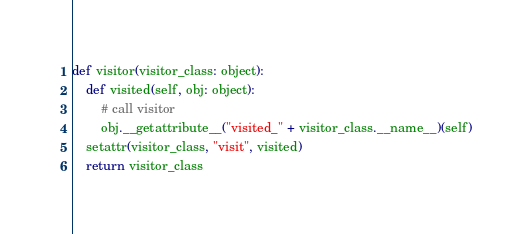<code> <loc_0><loc_0><loc_500><loc_500><_Python_>def visitor(visitor_class: object):
    def visited(self, obj: object):
        # call visitor
        obj.__getattribute__("visited_" + visitor_class.__name__)(self)
    setattr(visitor_class, "visit", visited)
    return visitor_class
</code> 